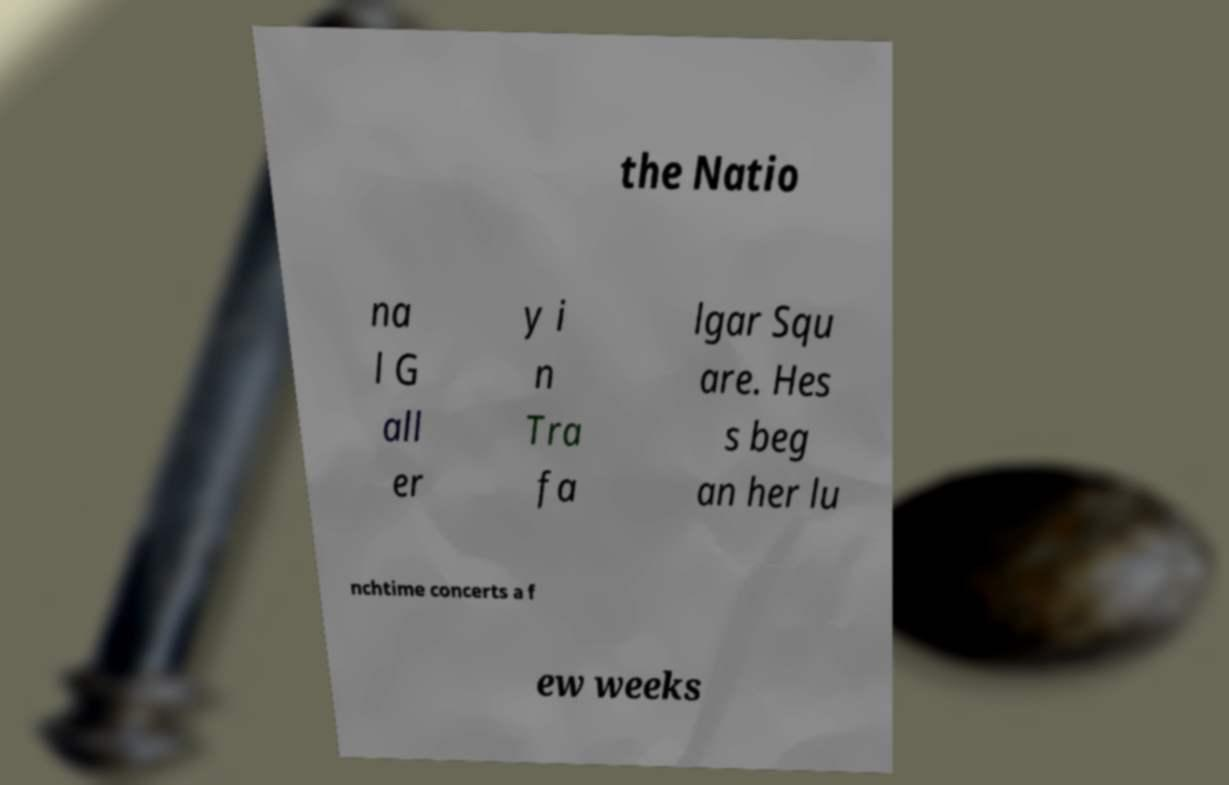What messages or text are displayed in this image? I need them in a readable, typed format. the Natio na l G all er y i n Tra fa lgar Squ are. Hes s beg an her lu nchtime concerts a f ew weeks 